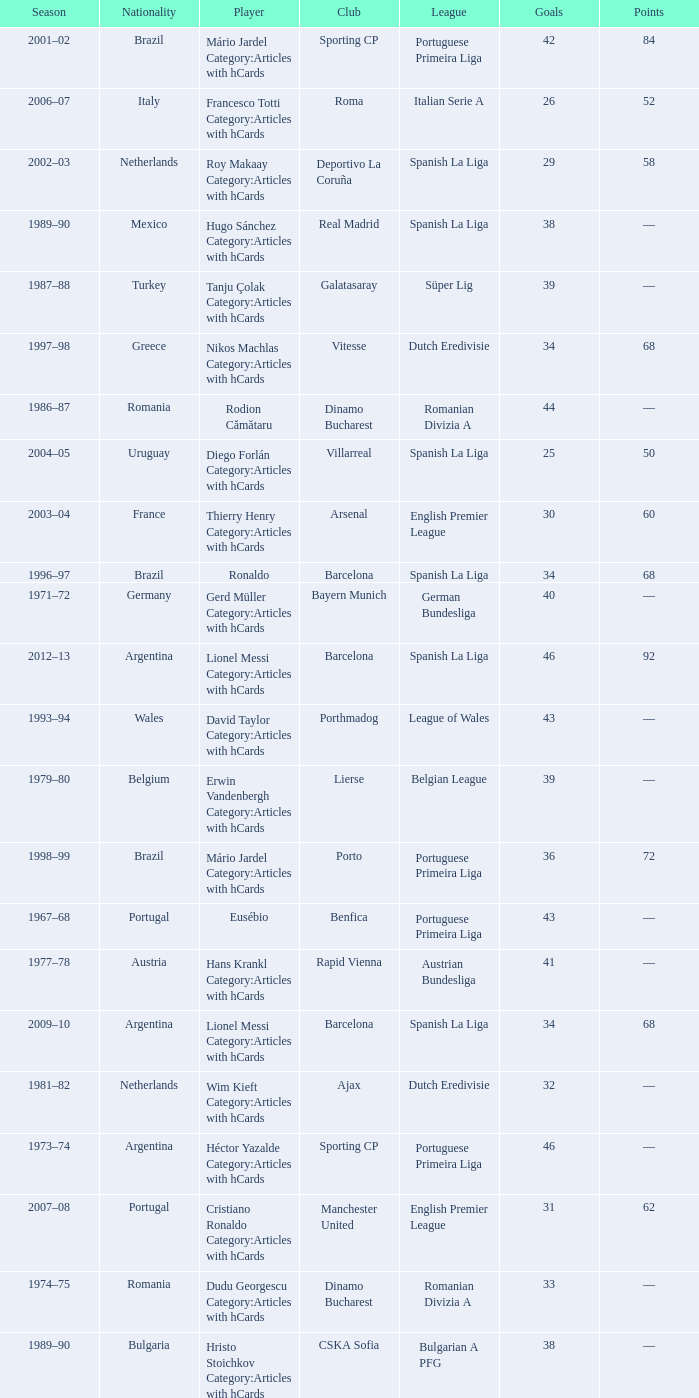Which player was in the Omonia Nicosia club? Sotiris Kaiafas Category:Articles with hCards. 